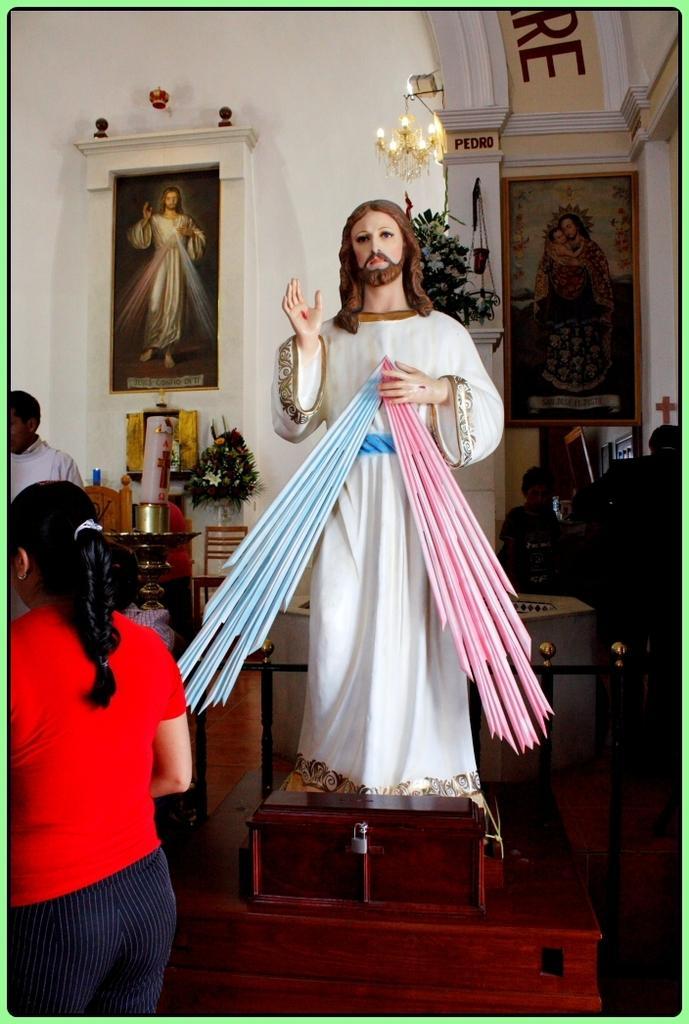Could you give a brief overview of what you see in this image? In this picture there is a statue in the center of the image and there are people on the right and left side of the image, there are portraits on the wall, in the background area of the image. 